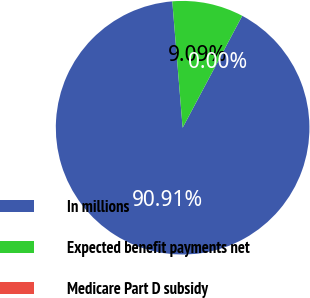Convert chart to OTSL. <chart><loc_0><loc_0><loc_500><loc_500><pie_chart><fcel>In millions<fcel>Expected benefit payments net<fcel>Medicare Part D subsidy<nl><fcel>90.91%<fcel>9.09%<fcel>0.0%<nl></chart> 